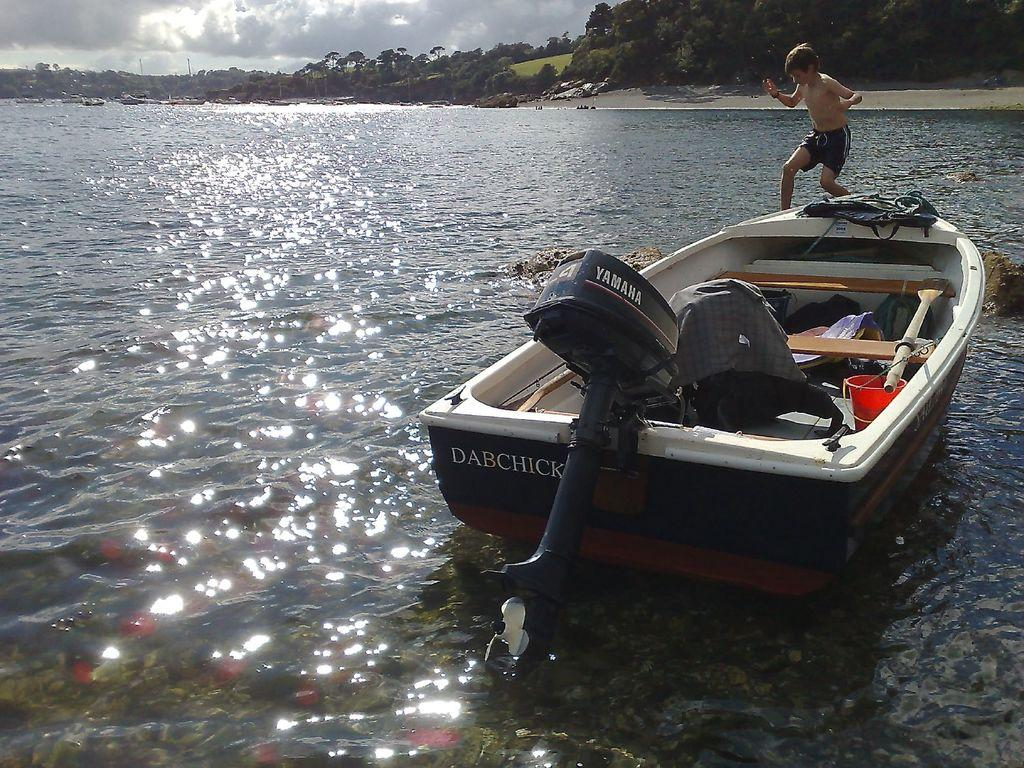What is in the water in the image? There is a boat in the water in the image. What can be found inside the boat? There is a bucket and other things in the boat. Who is in the boat? There is a boy wearing shorts in the boat. What is visible in the background of the image? Trees are visible in the image. How would you describe the weather based on the image? The sky is cloudy in the image. What type of shoes is the boy wearing in the image? There is no mention of shoes in the image; the boy is wearing shorts, but no shoes are visible. 